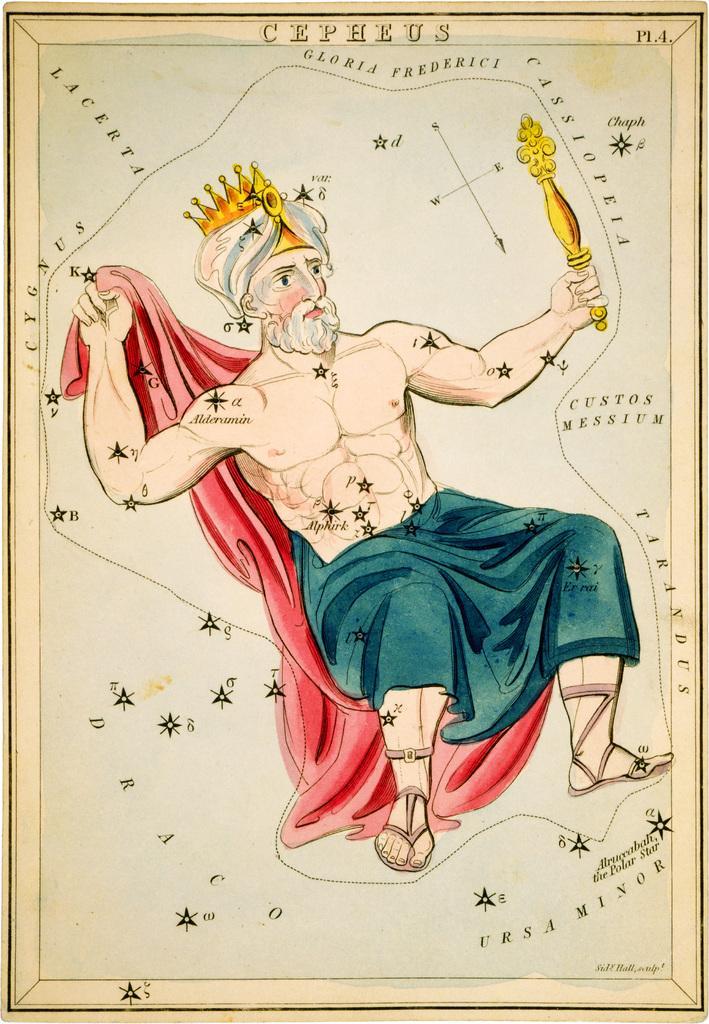Please provide a concise description of this image. In this image we can see a man holding red color cloth and has a crown on his head. 